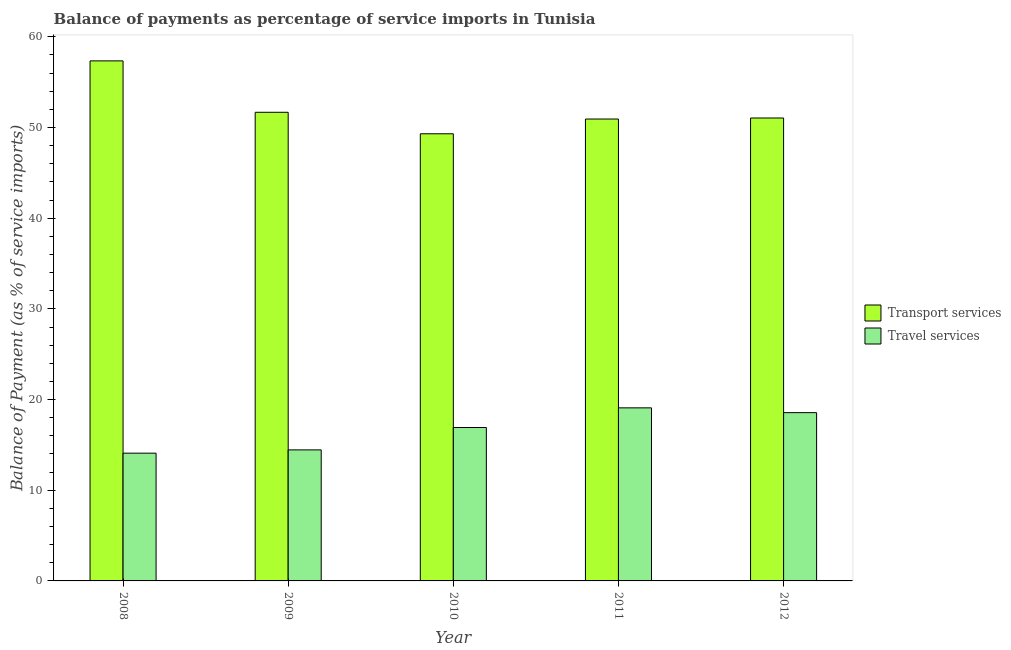How many different coloured bars are there?
Keep it short and to the point. 2. Are the number of bars per tick equal to the number of legend labels?
Keep it short and to the point. Yes. Are the number of bars on each tick of the X-axis equal?
Offer a terse response. Yes. What is the label of the 2nd group of bars from the left?
Offer a terse response. 2009. In how many cases, is the number of bars for a given year not equal to the number of legend labels?
Provide a short and direct response. 0. What is the balance of payments of transport services in 2008?
Give a very brief answer. 57.35. Across all years, what is the maximum balance of payments of transport services?
Your response must be concise. 57.35. Across all years, what is the minimum balance of payments of transport services?
Make the answer very short. 49.31. What is the total balance of payments of transport services in the graph?
Provide a short and direct response. 260.34. What is the difference between the balance of payments of travel services in 2009 and that in 2012?
Give a very brief answer. -4.11. What is the difference between the balance of payments of transport services in 2008 and the balance of payments of travel services in 2010?
Offer a terse response. 8.04. What is the average balance of payments of transport services per year?
Provide a succinct answer. 52.07. What is the ratio of the balance of payments of travel services in 2009 to that in 2010?
Provide a short and direct response. 0.85. Is the balance of payments of travel services in 2008 less than that in 2010?
Ensure brevity in your answer.  Yes. What is the difference between the highest and the second highest balance of payments of travel services?
Offer a very short reply. 0.53. What is the difference between the highest and the lowest balance of payments of transport services?
Provide a short and direct response. 8.04. In how many years, is the balance of payments of transport services greater than the average balance of payments of transport services taken over all years?
Give a very brief answer. 1. What does the 2nd bar from the left in 2009 represents?
Offer a terse response. Travel services. What does the 2nd bar from the right in 2012 represents?
Your response must be concise. Transport services. How many bars are there?
Provide a succinct answer. 10. Are all the bars in the graph horizontal?
Provide a short and direct response. No. What is the difference between two consecutive major ticks on the Y-axis?
Give a very brief answer. 10. Are the values on the major ticks of Y-axis written in scientific E-notation?
Offer a terse response. No. Does the graph contain any zero values?
Give a very brief answer. No. Does the graph contain grids?
Ensure brevity in your answer.  No. Where does the legend appear in the graph?
Provide a succinct answer. Center right. How many legend labels are there?
Provide a short and direct response. 2. What is the title of the graph?
Your answer should be very brief. Balance of payments as percentage of service imports in Tunisia. What is the label or title of the X-axis?
Your answer should be compact. Year. What is the label or title of the Y-axis?
Your answer should be compact. Balance of Payment (as % of service imports). What is the Balance of Payment (as % of service imports) in Transport services in 2008?
Offer a terse response. 57.35. What is the Balance of Payment (as % of service imports) of Travel services in 2008?
Offer a terse response. 14.09. What is the Balance of Payment (as % of service imports) of Transport services in 2009?
Your answer should be compact. 51.68. What is the Balance of Payment (as % of service imports) in Travel services in 2009?
Your response must be concise. 14.45. What is the Balance of Payment (as % of service imports) of Transport services in 2010?
Keep it short and to the point. 49.31. What is the Balance of Payment (as % of service imports) in Travel services in 2010?
Ensure brevity in your answer.  16.92. What is the Balance of Payment (as % of service imports) in Transport services in 2011?
Give a very brief answer. 50.94. What is the Balance of Payment (as % of service imports) in Travel services in 2011?
Provide a succinct answer. 19.09. What is the Balance of Payment (as % of service imports) of Transport services in 2012?
Make the answer very short. 51.05. What is the Balance of Payment (as % of service imports) in Travel services in 2012?
Offer a terse response. 18.56. Across all years, what is the maximum Balance of Payment (as % of service imports) in Transport services?
Keep it short and to the point. 57.35. Across all years, what is the maximum Balance of Payment (as % of service imports) in Travel services?
Provide a short and direct response. 19.09. Across all years, what is the minimum Balance of Payment (as % of service imports) of Transport services?
Make the answer very short. 49.31. Across all years, what is the minimum Balance of Payment (as % of service imports) of Travel services?
Your answer should be compact. 14.09. What is the total Balance of Payment (as % of service imports) of Transport services in the graph?
Offer a very short reply. 260.34. What is the total Balance of Payment (as % of service imports) of Travel services in the graph?
Provide a short and direct response. 83.1. What is the difference between the Balance of Payment (as % of service imports) of Transport services in 2008 and that in 2009?
Give a very brief answer. 5.67. What is the difference between the Balance of Payment (as % of service imports) of Travel services in 2008 and that in 2009?
Provide a succinct answer. -0.36. What is the difference between the Balance of Payment (as % of service imports) of Transport services in 2008 and that in 2010?
Give a very brief answer. 8.04. What is the difference between the Balance of Payment (as % of service imports) of Travel services in 2008 and that in 2010?
Your response must be concise. -2.83. What is the difference between the Balance of Payment (as % of service imports) of Transport services in 2008 and that in 2011?
Your answer should be very brief. 6.41. What is the difference between the Balance of Payment (as % of service imports) in Travel services in 2008 and that in 2011?
Your answer should be compact. -5. What is the difference between the Balance of Payment (as % of service imports) in Transport services in 2008 and that in 2012?
Your answer should be very brief. 6.3. What is the difference between the Balance of Payment (as % of service imports) of Travel services in 2008 and that in 2012?
Your answer should be compact. -4.47. What is the difference between the Balance of Payment (as % of service imports) in Transport services in 2009 and that in 2010?
Provide a short and direct response. 2.37. What is the difference between the Balance of Payment (as % of service imports) in Travel services in 2009 and that in 2010?
Offer a terse response. -2.47. What is the difference between the Balance of Payment (as % of service imports) of Transport services in 2009 and that in 2011?
Ensure brevity in your answer.  0.74. What is the difference between the Balance of Payment (as % of service imports) of Travel services in 2009 and that in 2011?
Provide a short and direct response. -4.64. What is the difference between the Balance of Payment (as % of service imports) in Transport services in 2009 and that in 2012?
Your answer should be compact. 0.63. What is the difference between the Balance of Payment (as % of service imports) of Travel services in 2009 and that in 2012?
Your answer should be very brief. -4.11. What is the difference between the Balance of Payment (as % of service imports) in Transport services in 2010 and that in 2011?
Offer a very short reply. -1.63. What is the difference between the Balance of Payment (as % of service imports) of Travel services in 2010 and that in 2011?
Offer a very short reply. -2.17. What is the difference between the Balance of Payment (as % of service imports) of Transport services in 2010 and that in 2012?
Make the answer very short. -1.74. What is the difference between the Balance of Payment (as % of service imports) of Travel services in 2010 and that in 2012?
Provide a succinct answer. -1.64. What is the difference between the Balance of Payment (as % of service imports) in Transport services in 2011 and that in 2012?
Ensure brevity in your answer.  -0.11. What is the difference between the Balance of Payment (as % of service imports) of Travel services in 2011 and that in 2012?
Your answer should be very brief. 0.53. What is the difference between the Balance of Payment (as % of service imports) in Transport services in 2008 and the Balance of Payment (as % of service imports) in Travel services in 2009?
Keep it short and to the point. 42.9. What is the difference between the Balance of Payment (as % of service imports) of Transport services in 2008 and the Balance of Payment (as % of service imports) of Travel services in 2010?
Offer a terse response. 40.43. What is the difference between the Balance of Payment (as % of service imports) in Transport services in 2008 and the Balance of Payment (as % of service imports) in Travel services in 2011?
Your answer should be compact. 38.26. What is the difference between the Balance of Payment (as % of service imports) in Transport services in 2008 and the Balance of Payment (as % of service imports) in Travel services in 2012?
Your response must be concise. 38.79. What is the difference between the Balance of Payment (as % of service imports) in Transport services in 2009 and the Balance of Payment (as % of service imports) in Travel services in 2010?
Your response must be concise. 34.76. What is the difference between the Balance of Payment (as % of service imports) of Transport services in 2009 and the Balance of Payment (as % of service imports) of Travel services in 2011?
Offer a very short reply. 32.59. What is the difference between the Balance of Payment (as % of service imports) in Transport services in 2009 and the Balance of Payment (as % of service imports) in Travel services in 2012?
Your answer should be very brief. 33.12. What is the difference between the Balance of Payment (as % of service imports) in Transport services in 2010 and the Balance of Payment (as % of service imports) in Travel services in 2011?
Provide a succinct answer. 30.22. What is the difference between the Balance of Payment (as % of service imports) of Transport services in 2010 and the Balance of Payment (as % of service imports) of Travel services in 2012?
Your answer should be very brief. 30.76. What is the difference between the Balance of Payment (as % of service imports) of Transport services in 2011 and the Balance of Payment (as % of service imports) of Travel services in 2012?
Offer a very short reply. 32.38. What is the average Balance of Payment (as % of service imports) in Transport services per year?
Make the answer very short. 52.07. What is the average Balance of Payment (as % of service imports) in Travel services per year?
Offer a terse response. 16.62. In the year 2008, what is the difference between the Balance of Payment (as % of service imports) of Transport services and Balance of Payment (as % of service imports) of Travel services?
Give a very brief answer. 43.26. In the year 2009, what is the difference between the Balance of Payment (as % of service imports) in Transport services and Balance of Payment (as % of service imports) in Travel services?
Give a very brief answer. 37.23. In the year 2010, what is the difference between the Balance of Payment (as % of service imports) in Transport services and Balance of Payment (as % of service imports) in Travel services?
Give a very brief answer. 32.39. In the year 2011, what is the difference between the Balance of Payment (as % of service imports) of Transport services and Balance of Payment (as % of service imports) of Travel services?
Ensure brevity in your answer.  31.85. In the year 2012, what is the difference between the Balance of Payment (as % of service imports) of Transport services and Balance of Payment (as % of service imports) of Travel services?
Offer a terse response. 32.5. What is the ratio of the Balance of Payment (as % of service imports) in Transport services in 2008 to that in 2009?
Offer a very short reply. 1.11. What is the ratio of the Balance of Payment (as % of service imports) of Travel services in 2008 to that in 2009?
Ensure brevity in your answer.  0.97. What is the ratio of the Balance of Payment (as % of service imports) in Transport services in 2008 to that in 2010?
Your answer should be compact. 1.16. What is the ratio of the Balance of Payment (as % of service imports) of Travel services in 2008 to that in 2010?
Ensure brevity in your answer.  0.83. What is the ratio of the Balance of Payment (as % of service imports) in Transport services in 2008 to that in 2011?
Ensure brevity in your answer.  1.13. What is the ratio of the Balance of Payment (as % of service imports) of Travel services in 2008 to that in 2011?
Your answer should be very brief. 0.74. What is the ratio of the Balance of Payment (as % of service imports) in Transport services in 2008 to that in 2012?
Your answer should be compact. 1.12. What is the ratio of the Balance of Payment (as % of service imports) in Travel services in 2008 to that in 2012?
Your response must be concise. 0.76. What is the ratio of the Balance of Payment (as % of service imports) of Transport services in 2009 to that in 2010?
Provide a short and direct response. 1.05. What is the ratio of the Balance of Payment (as % of service imports) in Travel services in 2009 to that in 2010?
Offer a terse response. 0.85. What is the ratio of the Balance of Payment (as % of service imports) in Transport services in 2009 to that in 2011?
Make the answer very short. 1.01. What is the ratio of the Balance of Payment (as % of service imports) in Travel services in 2009 to that in 2011?
Ensure brevity in your answer.  0.76. What is the ratio of the Balance of Payment (as % of service imports) of Transport services in 2009 to that in 2012?
Offer a very short reply. 1.01. What is the ratio of the Balance of Payment (as % of service imports) in Travel services in 2009 to that in 2012?
Your response must be concise. 0.78. What is the ratio of the Balance of Payment (as % of service imports) in Transport services in 2010 to that in 2011?
Give a very brief answer. 0.97. What is the ratio of the Balance of Payment (as % of service imports) of Travel services in 2010 to that in 2011?
Offer a very short reply. 0.89. What is the ratio of the Balance of Payment (as % of service imports) of Transport services in 2010 to that in 2012?
Your answer should be very brief. 0.97. What is the ratio of the Balance of Payment (as % of service imports) of Travel services in 2010 to that in 2012?
Keep it short and to the point. 0.91. What is the ratio of the Balance of Payment (as % of service imports) of Travel services in 2011 to that in 2012?
Your answer should be very brief. 1.03. What is the difference between the highest and the second highest Balance of Payment (as % of service imports) of Transport services?
Your answer should be compact. 5.67. What is the difference between the highest and the second highest Balance of Payment (as % of service imports) of Travel services?
Offer a terse response. 0.53. What is the difference between the highest and the lowest Balance of Payment (as % of service imports) of Transport services?
Your answer should be very brief. 8.04. What is the difference between the highest and the lowest Balance of Payment (as % of service imports) in Travel services?
Keep it short and to the point. 5. 